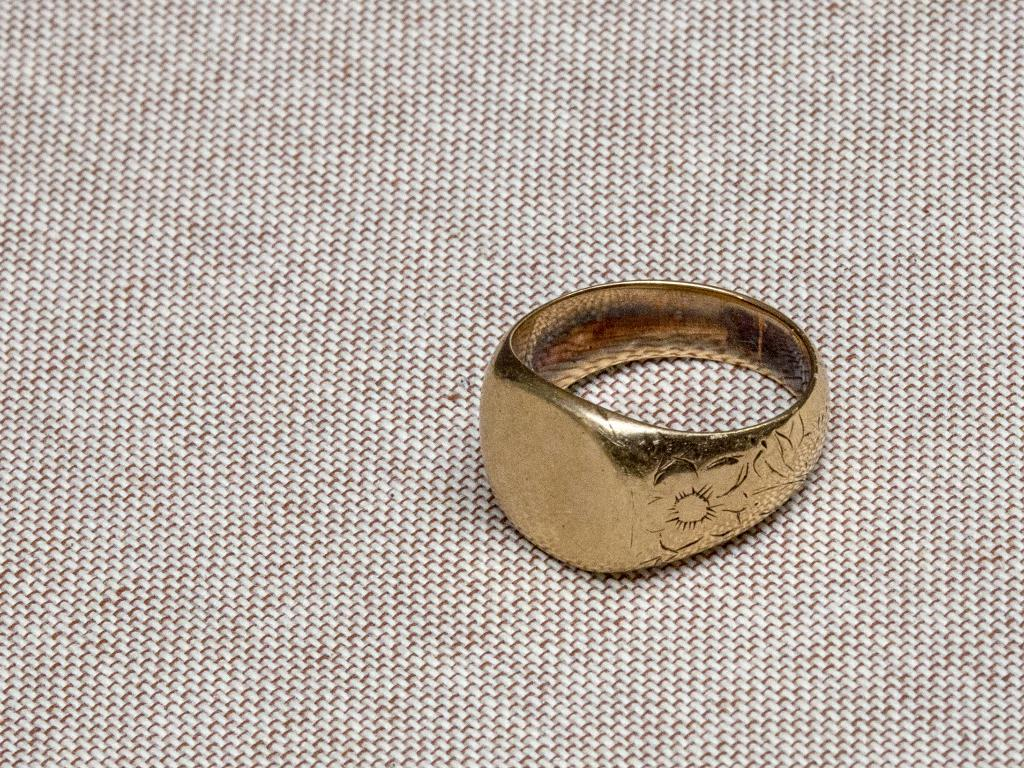What is the main object in the image? There is a ring in the image. What is the color of the ring? The ring is gold in color. On what surface is the ring placed? The ring is on a cream-colored surface. How many beads are strung together on the ring in the image? There are no beads present on the ring in the image. What type of machine is used to create the ring in the image? There is no machine present in the image, and the process of creating the ring is not depicted. 